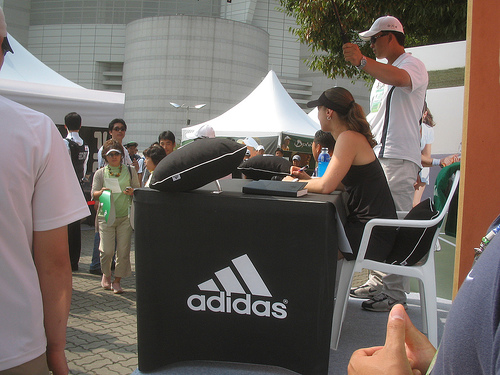<image>
Can you confirm if the woman is behind the table? Yes. From this viewpoint, the woman is positioned behind the table, with the table partially or fully occluding the woman. 